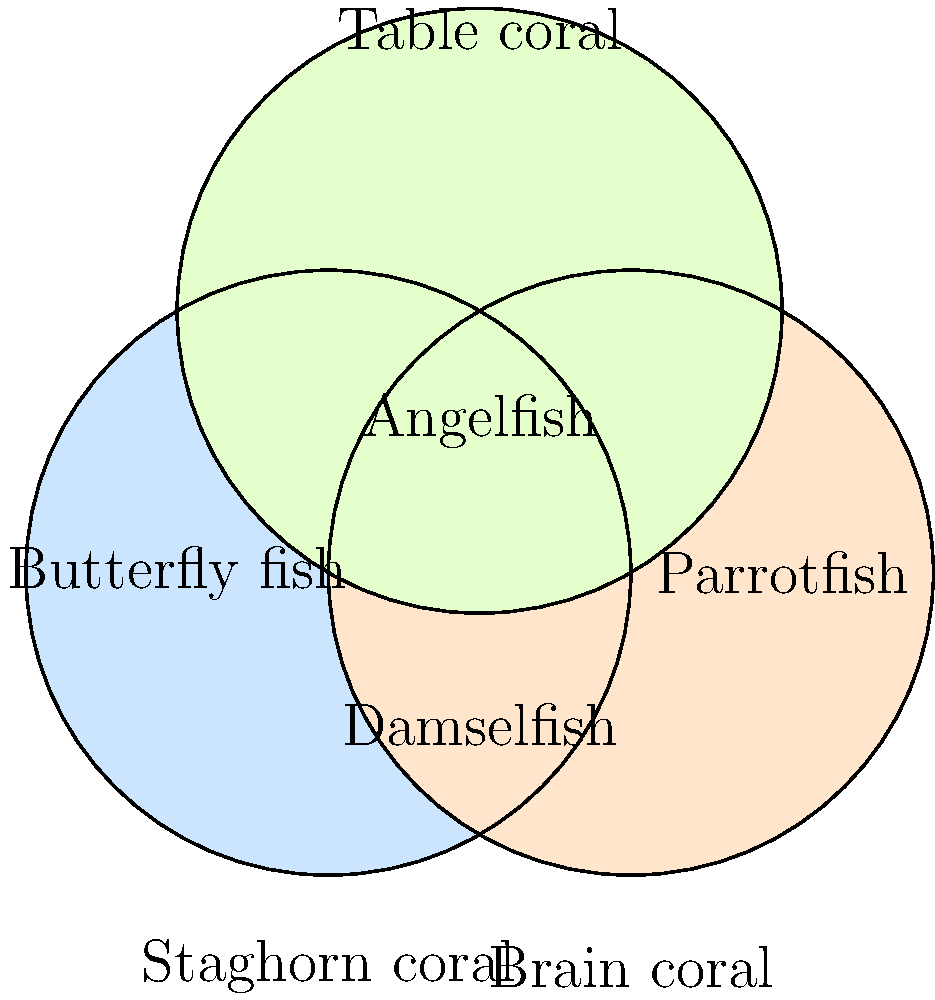In the Venn diagram above, three overlapping circles represent different coral habitats: Staghorn coral, Brain coral, and Table coral. Four fish species (Butterfly fish, Parrotfish, Damselfish, and Angelfish) are placed in different regions. Based on their positions, which fish species is most likely to be found in all three coral habitats? To determine which fish species is most likely to be found in all three coral habitats, we need to analyze the Venn diagram:

1. The three circles represent:
   - Staghorn coral (left circle)
   - Brain coral (right circle)
   - Table coral (top circle)

2. The overlapping region in the center represents the area where all three coral habitats intersect.

3. Examining the positions of the fish species:
   - Butterfly fish is only in the Staghorn coral region
   - Parrotfish is only in the Brain coral region
   - Damselfish is in the overlapping area between Staghorn and Brain coral
   - Angelfish is in the center, where all three circles overlap

4. The fish species located in the center of the diagram, where all three circles intersect, is the one most likely to be found in all three coral habitats.

5. Therefore, the Angelfish is positioned in the region that represents all three coral habitats.
Answer: Angelfish 